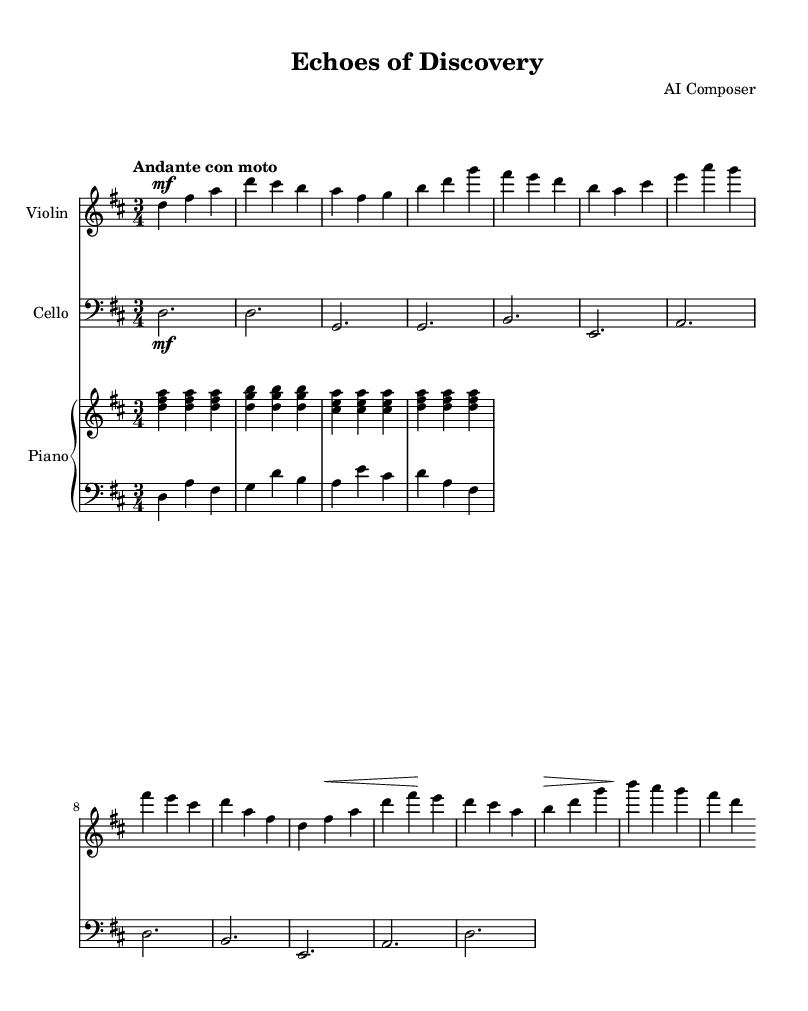What is the key signature of this music? The key signature is D major, which has two sharps: F# and C#.
Answer: D major What is the time signature of the piece? The time signature is indicated as 3/4, meaning there are three beats in each measure and the quarter note receives one beat.
Answer: 3/4 What is the tempo marking for this piece? The tempo marking is "Andante con moto," which translates to a moderately slow pace with a bit of motion.
Answer: Andante con moto How many measures are in the violin part? The violin part contains 12 measures, which can be counted by reviewing the bar lines in the music.
Answer: 12 Which dynamics are indicated for the cello part? The cello part is marked with a mezzo-forte (mf) dynamic, indicating a moderately loud volume for the first measure, but no additional dynamics are shown.
Answer: mezzo-forte What is the role of the piano in this chamber music piece? The piano serves as both harmonic support and provides rhythmic contrast, as indicated by the combination of both right and left hand parts in the score.
Answer: Harmonic support Does the piece employ counterpoint? Yes, counterpoint is used in this piece, as the different instruments (violin, cello, and piano) play distinct melodic lines that interact with each other harmonically.
Answer: Yes 